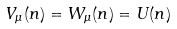<formula> <loc_0><loc_0><loc_500><loc_500>V _ { \mu } ( n ) = W _ { \mu } ( n ) = U ( n )</formula> 